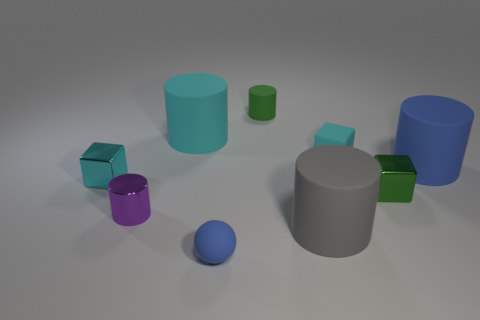Do the small green object that is behind the large cyan object and the cyan block on the left side of the large cyan cylinder have the same material?
Give a very brief answer. No. What is the material of the cyan cylinder?
Provide a succinct answer. Rubber. How many other things are there of the same color as the rubber block?
Ensure brevity in your answer.  2. Does the tiny matte ball have the same color as the metal cylinder?
Keep it short and to the point. No. How many tiny cyan blocks are there?
Offer a very short reply. 2. There is a block that is in front of the tiny metallic block to the left of the big cyan rubber thing; what is it made of?
Your response must be concise. Metal. There is a green cylinder that is the same size as the cyan shiny object; what is it made of?
Ensure brevity in your answer.  Rubber. There is a blue rubber thing that is right of the blue sphere; is its size the same as the small purple metallic cylinder?
Offer a terse response. No. There is a tiny cyan object on the left side of the rubber sphere; is its shape the same as the big blue rubber object?
Offer a very short reply. No. How many objects are either large gray spheres or matte things that are behind the matte cube?
Your response must be concise. 2. 